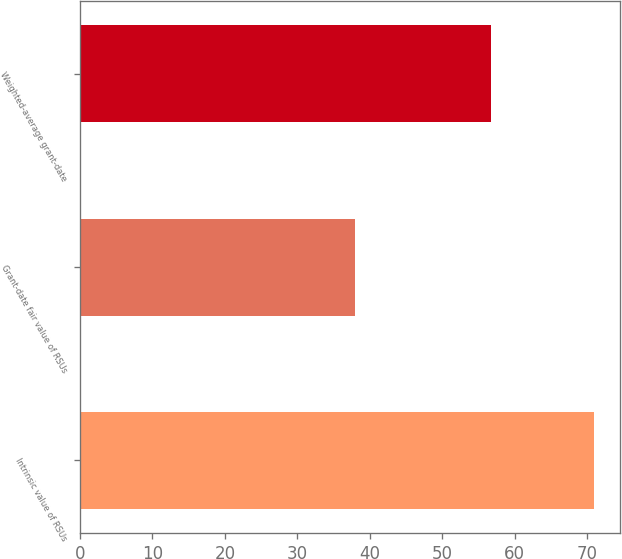Convert chart to OTSL. <chart><loc_0><loc_0><loc_500><loc_500><bar_chart><fcel>Intrinsic value of RSUs<fcel>Grant-date fair value of RSUs<fcel>Weighted-average grant-date<nl><fcel>71<fcel>38<fcel>56.71<nl></chart> 